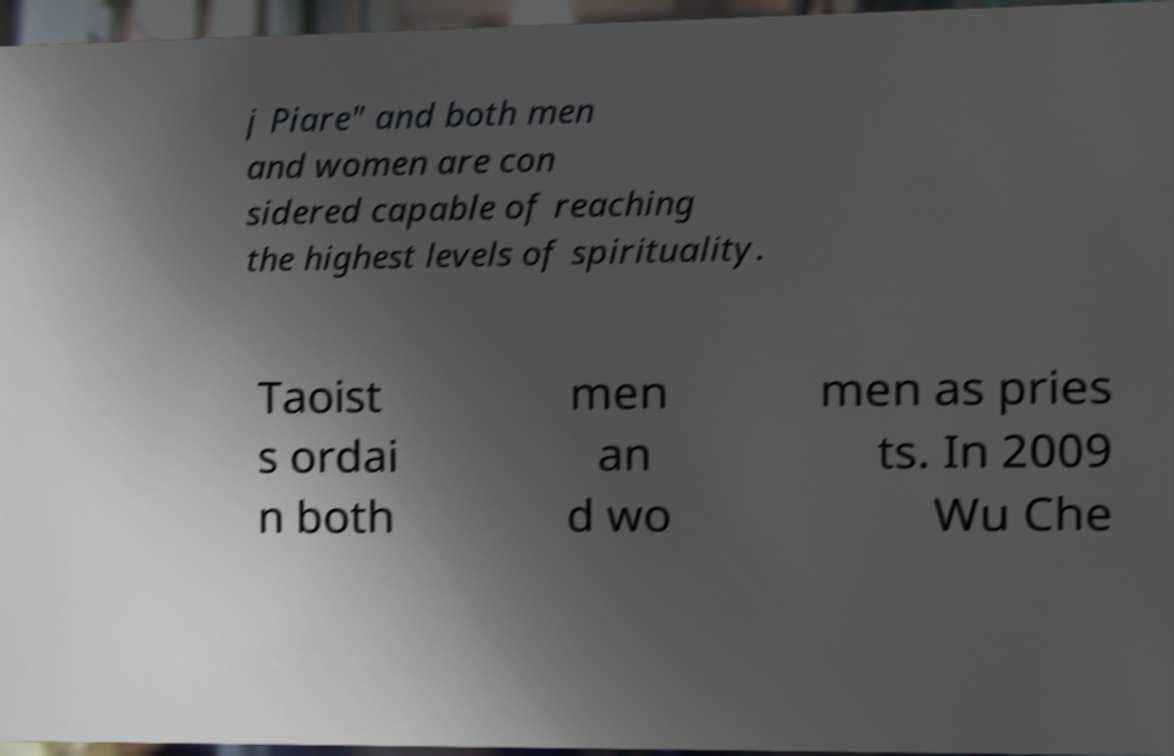For documentation purposes, I need the text within this image transcribed. Could you provide that? j Piare" and both men and women are con sidered capable of reaching the highest levels of spirituality. Taoist s ordai n both men an d wo men as pries ts. In 2009 Wu Che 